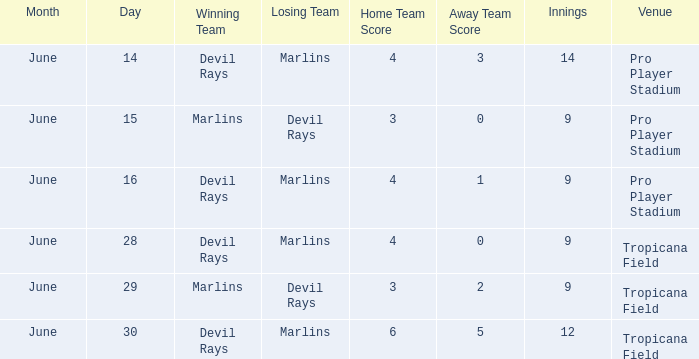What was the score on june 29? 3-2. 